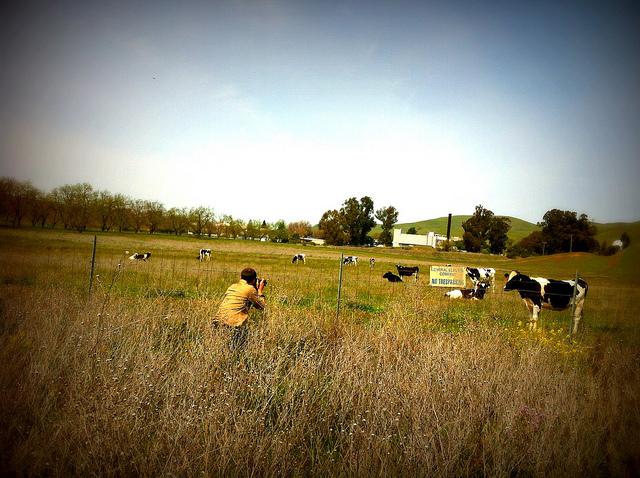What animals are being fenced?
Concise answer only. Cows. What is the man doing?
Give a very brief answer. Taking pictures. What color is the man's shirt?
Keep it brief. Yellow. 